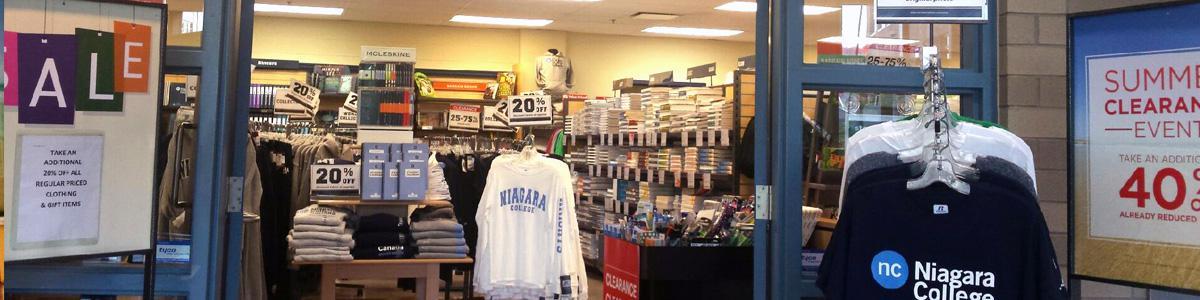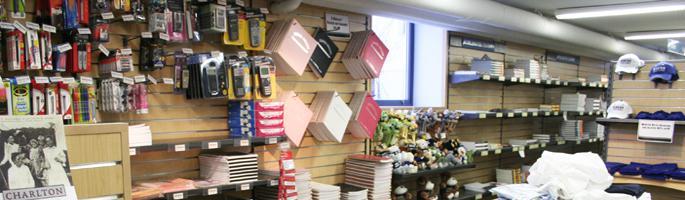The first image is the image on the left, the second image is the image on the right. Examine the images to the left and right. Is the description "IN at least one image there is only a single woman with long hair browsing the store." accurate? Answer yes or no. No. 